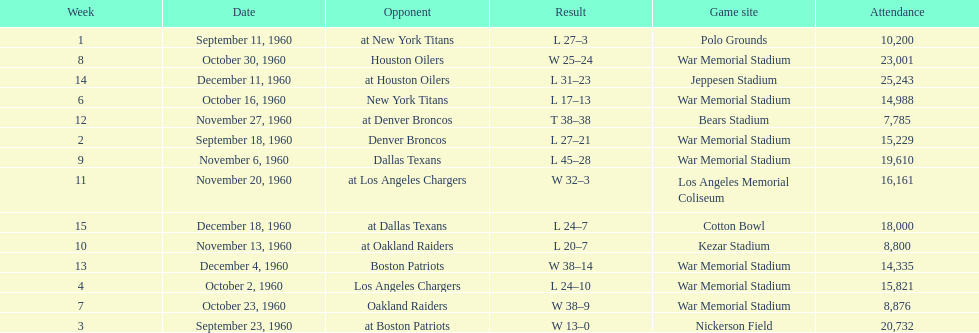Who did the bills play after the oakland raiders? Houston Oilers. 